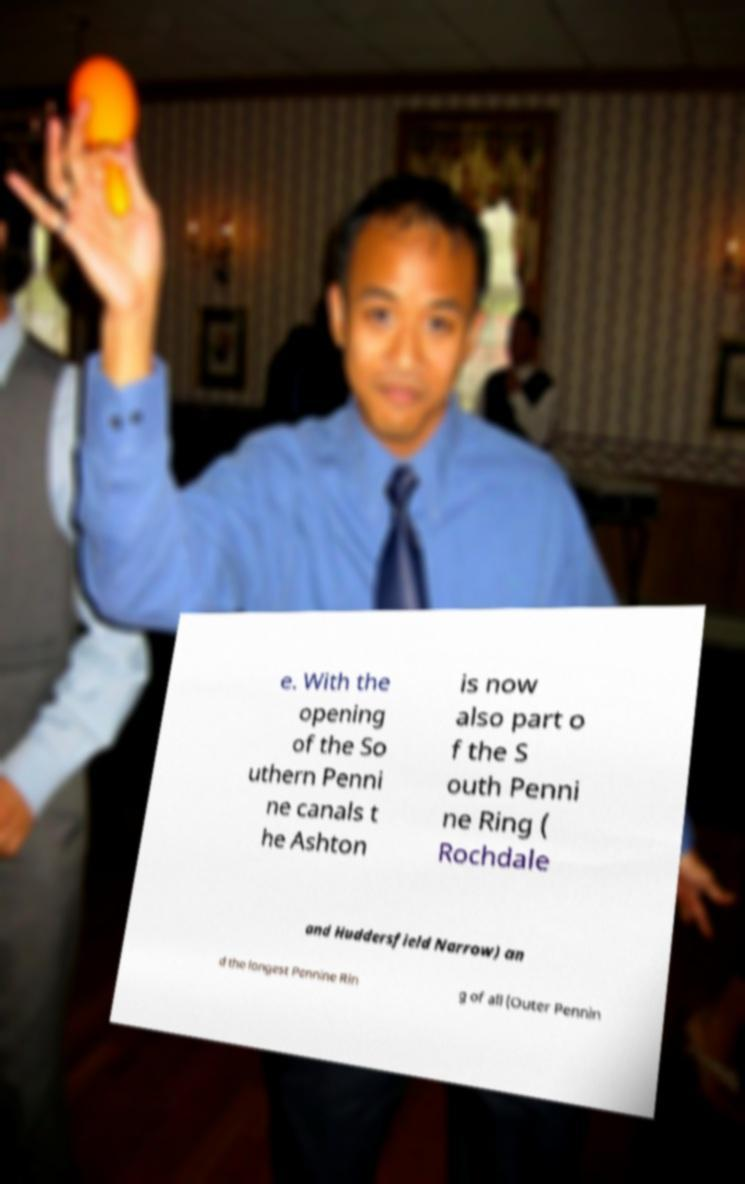Can you read and provide the text displayed in the image?This photo seems to have some interesting text. Can you extract and type it out for me? e. With the opening of the So uthern Penni ne canals t he Ashton is now also part o f the S outh Penni ne Ring ( Rochdale and Huddersfield Narrow) an d the longest Pennine Rin g of all (Outer Pennin 